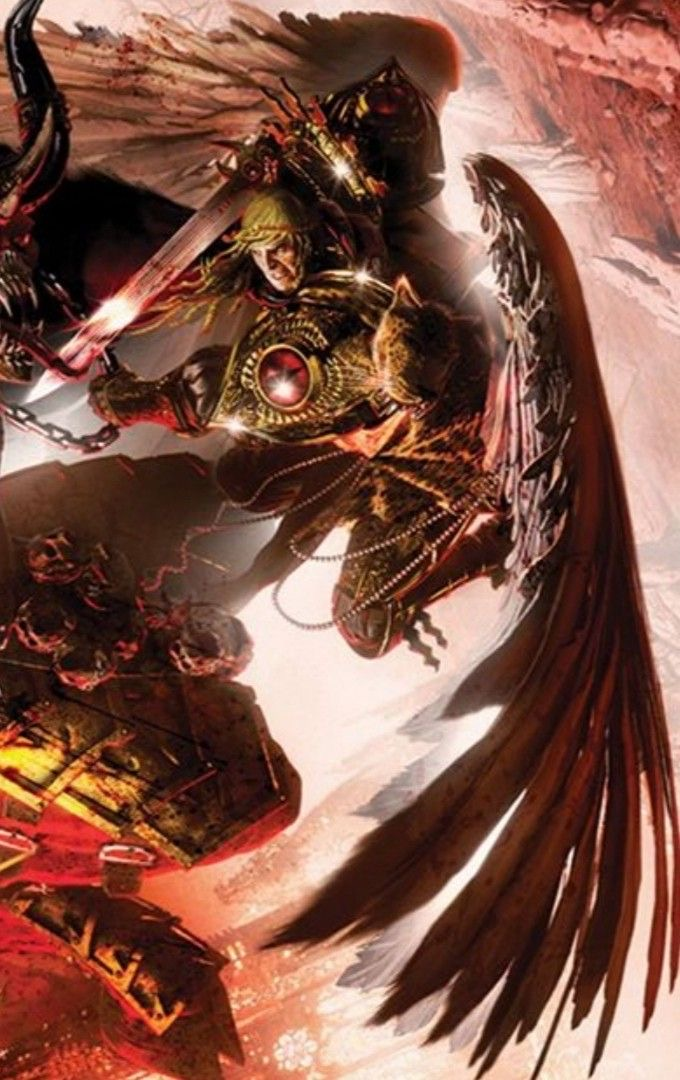Come up with a description for the content of this image (make it {extreme knowledge}, no more than 9 words!), while also describing the style of this image in detail. For the latter, look at the texture carefully to determine the techniqe used. Be specific. In that part, mention the style and exact content. Briefly describe the style as aptly as possible, don't say 'likely', make an straight forward response, giving great emphasis on the techniques used to generate such an image (dark fantasy artwork, for example, or max knowledge detail/ every exact even small details in the image), including details about how sparse/minimal or complex it is. Then provide your response in the following format, always using a | to separate the new content idea from the style descriptions: <content in the image>, | <details>, <small details>, <exact look and feel>, <colors used>. You will be inclined to say 'digital' if you're not sure, please only do that when you're certain, and go into full detail first. This image depicts a formidable, larger-than-life demonic entity | Highly detailed dark fantasy artwork, utilizing a combination of digital painting and intricate photobashing techniques to create a complex and visually striking composition. The texture and rendering showcase a meticulous level of craftsmanship, with a focus on capturing the intricate organic forms, ornate armor, and otherworldly feathered appendages of the creature. The overall aesthetic exudes a sense of power, menace, and a touch of the macabre, accentuated by the use of deep, saturated hues of red, gold, and black that imbue the scene with a sense of intense drama and intensity. 